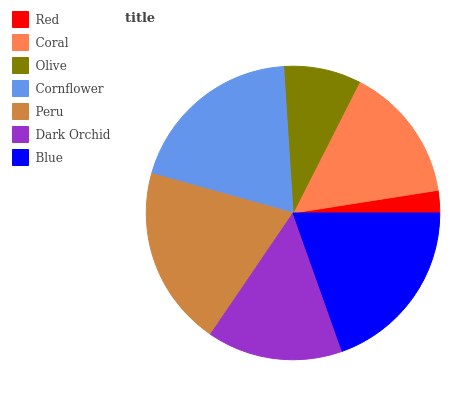Is Red the minimum?
Answer yes or no. Yes. Is Peru the maximum?
Answer yes or no. Yes. Is Coral the minimum?
Answer yes or no. No. Is Coral the maximum?
Answer yes or no. No. Is Coral greater than Red?
Answer yes or no. Yes. Is Red less than Coral?
Answer yes or no. Yes. Is Red greater than Coral?
Answer yes or no. No. Is Coral less than Red?
Answer yes or no. No. Is Coral the high median?
Answer yes or no. Yes. Is Coral the low median?
Answer yes or no. Yes. Is Olive the high median?
Answer yes or no. No. Is Blue the low median?
Answer yes or no. No. 